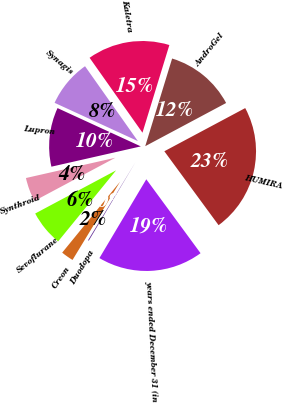<chart> <loc_0><loc_0><loc_500><loc_500><pie_chart><fcel>years ended December 31 (in<fcel>HUMIRA<fcel>AndroGel<fcel>Kaletra<fcel>Synagis<fcel>Lupron<fcel>Synthroid<fcel>Sevoflurane<fcel>Creon<fcel>Duodopa<nl><fcel>18.62%<fcel>22.73%<fcel>12.46%<fcel>14.52%<fcel>8.36%<fcel>10.41%<fcel>4.25%<fcel>6.31%<fcel>2.2%<fcel>0.15%<nl></chart> 